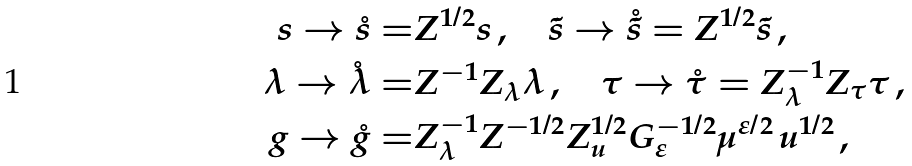Convert formula to latex. <formula><loc_0><loc_0><loc_500><loc_500>s \rightarrow \mathring { s } = & Z ^ { 1 / 2 } s \, , \quad \tilde { s } \rightarrow \mathring { \tilde { s } } = Z ^ { 1 / 2 } \tilde { s } \, , \\ \lambda \rightarrow \mathring { \lambda } = & Z ^ { - 1 } Z _ { \lambda } \lambda \, , \quad \tau \rightarrow \mathring { \tau } = Z _ { \lambda } ^ { - 1 } Z _ { \tau } \tau \, , \\ g \rightarrow \mathring { g } = & Z _ { \lambda } ^ { - 1 } Z ^ { - 1 / 2 } Z _ { u } ^ { 1 / 2 } G _ { \varepsilon } ^ { - 1 / 2 } \mu ^ { \varepsilon / 2 } \, u ^ { 1 / 2 } \, ,</formula> 